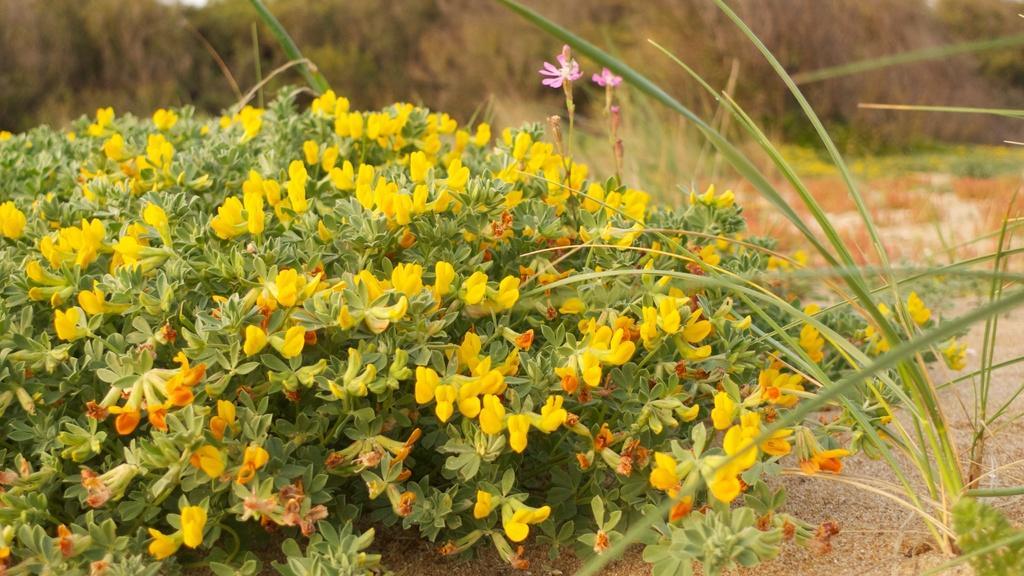In one or two sentences, can you explain what this image depicts? This image contains few plants having flowers. Right side there is grass. Background there are few plants on the land. 